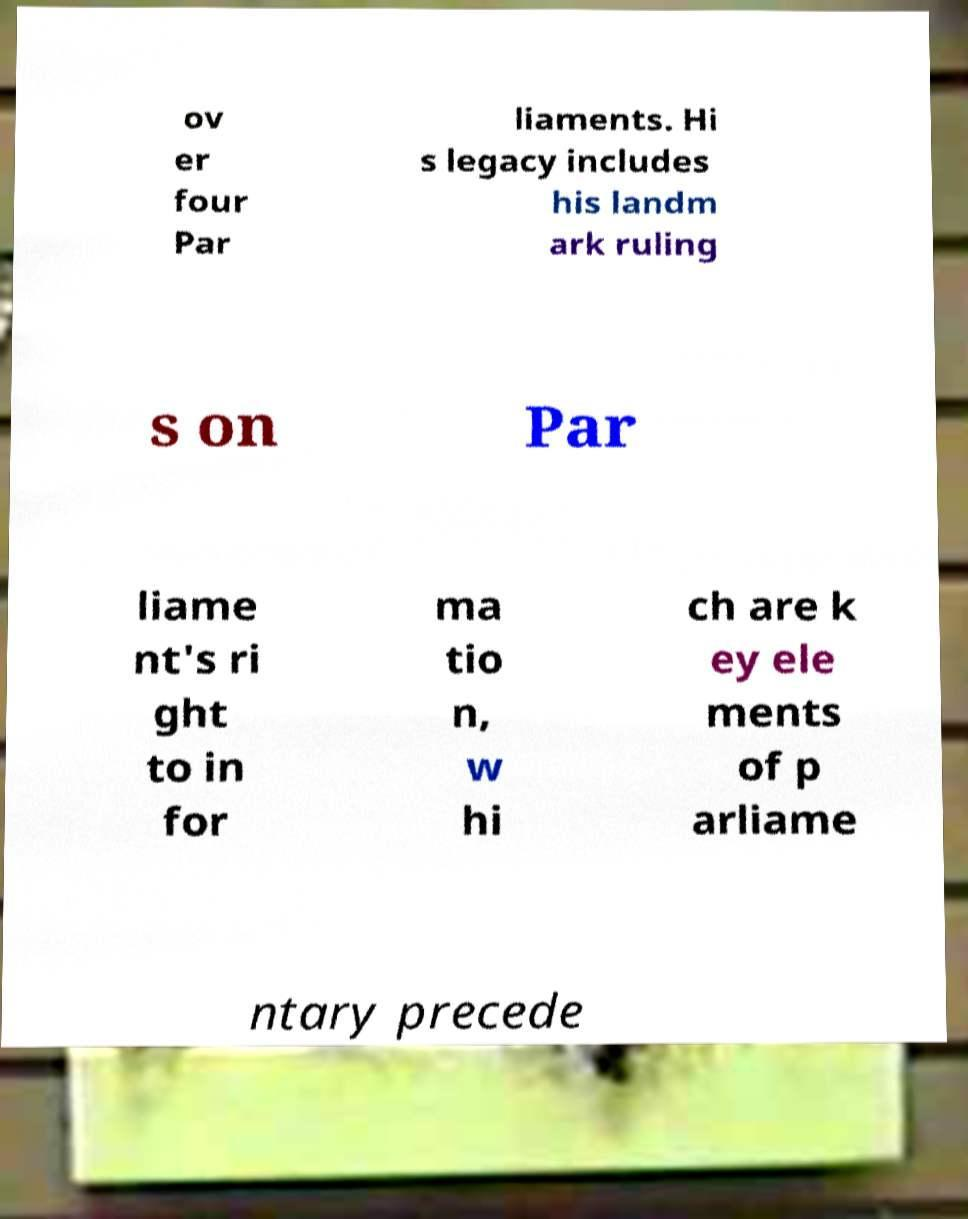What messages or text are displayed in this image? I need them in a readable, typed format. ov er four Par liaments. Hi s legacy includes his landm ark ruling s on Par liame nt's ri ght to in for ma tio n, w hi ch are k ey ele ments of p arliame ntary precede 